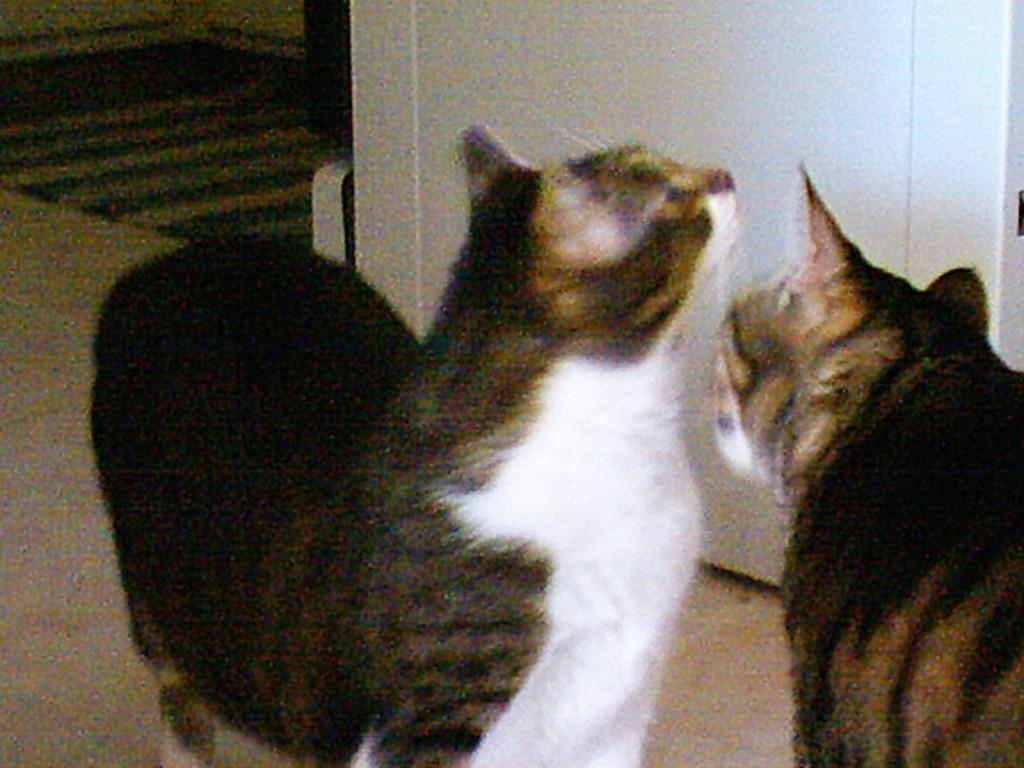What animals are in the center of the image? There are two cats in the center of the image. What structure can be seen in the image? There is a door in the image. What type of flooring is visible at the bottom of the image? There is a carpet at the bottom of the image. What type of suit is the plant wearing in the image? There is no plant or suit present in the image. 